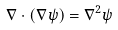<formula> <loc_0><loc_0><loc_500><loc_500>\nabla \cdot ( \nabla \psi ) = \nabla ^ { 2 } \psi</formula> 